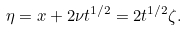Convert formula to latex. <formula><loc_0><loc_0><loc_500><loc_500>\eta = x + 2 \nu t ^ { 1 / 2 } = 2 t ^ { 1 / 2 } \zeta .</formula> 